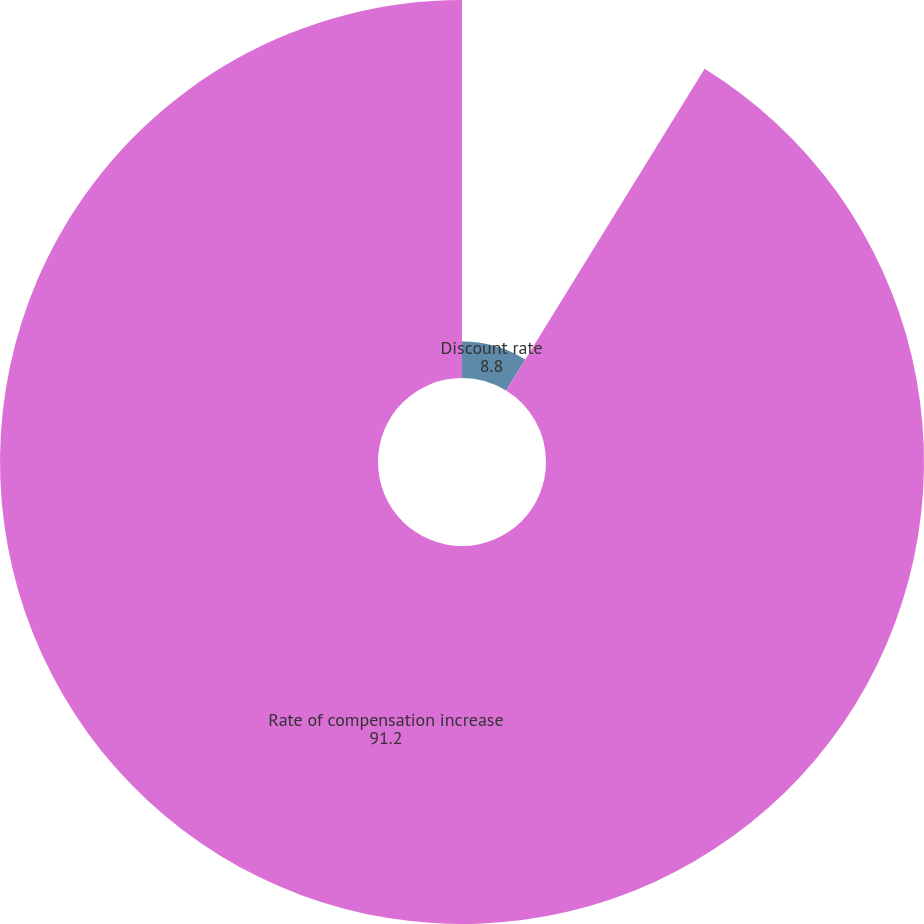Convert chart to OTSL. <chart><loc_0><loc_0><loc_500><loc_500><pie_chart><fcel>Discount rate<fcel>Rate of compensation increase<nl><fcel>8.8%<fcel>91.2%<nl></chart> 